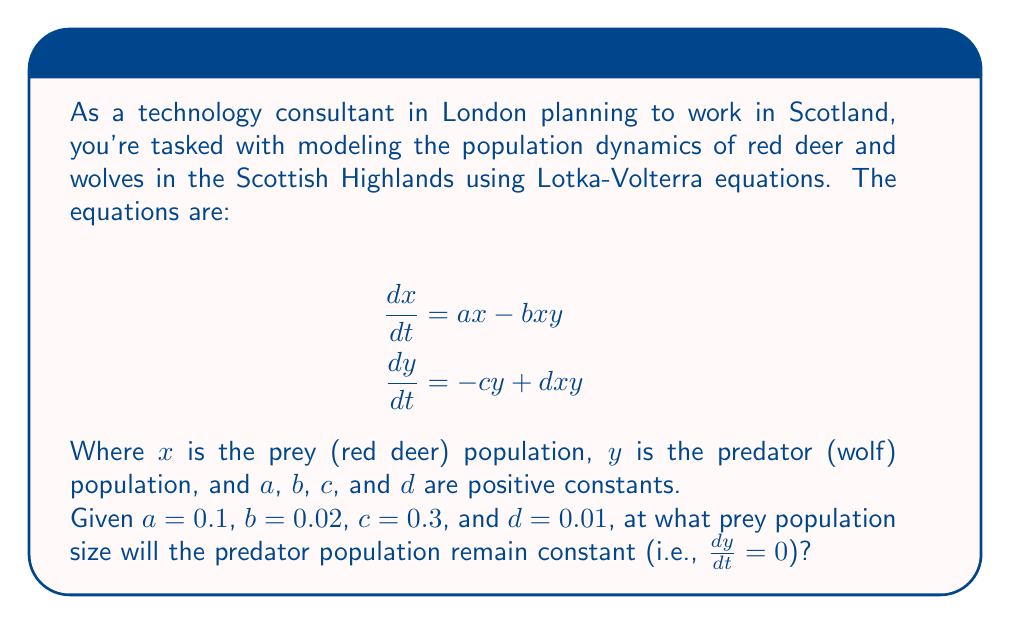Teach me how to tackle this problem. To solve this problem, we need to follow these steps:

1. Recall that for the predator population to remain constant, $\frac{dy}{dt} = 0$.

2. Use the second Lotka-Volterra equation:
   $$\frac{dy}{dt} = -cy + dxy$$

3. Set this equation equal to zero:
   $$0 = -cy + dxy$$

4. Factor out $y$:
   $$0 = y(-c + dx)$$

5. For this equation to be true (and $y$ to be non-zero), we must have:
   $$-c + dx = 0$$

6. Solve this equation for $x$:
   $$dx = c$$
   $$x = \frac{c}{d}$$

7. Substitute the given values $c=0.3$ and $d=0.01$:
   $$x = \frac{0.3}{0.01} = 30$$

Therefore, the prey population size at which the predator population will remain constant is 30 units.
Answer: 30 red deer 